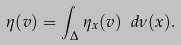Convert formula to latex. <formula><loc_0><loc_0><loc_500><loc_500>\eta ( v ) = \int _ { \Delta } \eta _ { x } ( v ) \ d \nu ( x ) .</formula> 